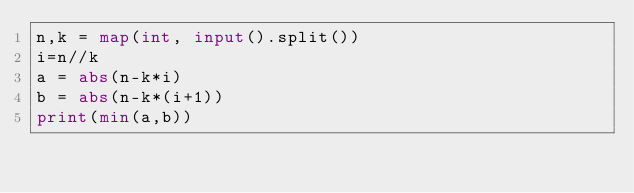Convert code to text. <code><loc_0><loc_0><loc_500><loc_500><_Python_>n,k = map(int, input().split())
i=n//k
a = abs(n-k*i)
b = abs(n-k*(i+1))
print(min(a,b))</code> 